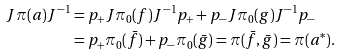<formula> <loc_0><loc_0><loc_500><loc_500>{ J } \pi ( a ) { J } ^ { - 1 } & = p _ { + } { J } \pi _ { 0 } ( f ) { J } ^ { - 1 } p _ { + } + p _ { - } { J } \pi _ { 0 } ( g ) { J } ^ { - 1 } p _ { - } \\ & = p _ { + } \pi _ { 0 } ( \bar { f } ) + p _ { - } \pi _ { 0 } ( \bar { g } ) = \pi ( \bar { f } , \bar { g } ) = \pi ( a ^ { * } ) .</formula> 